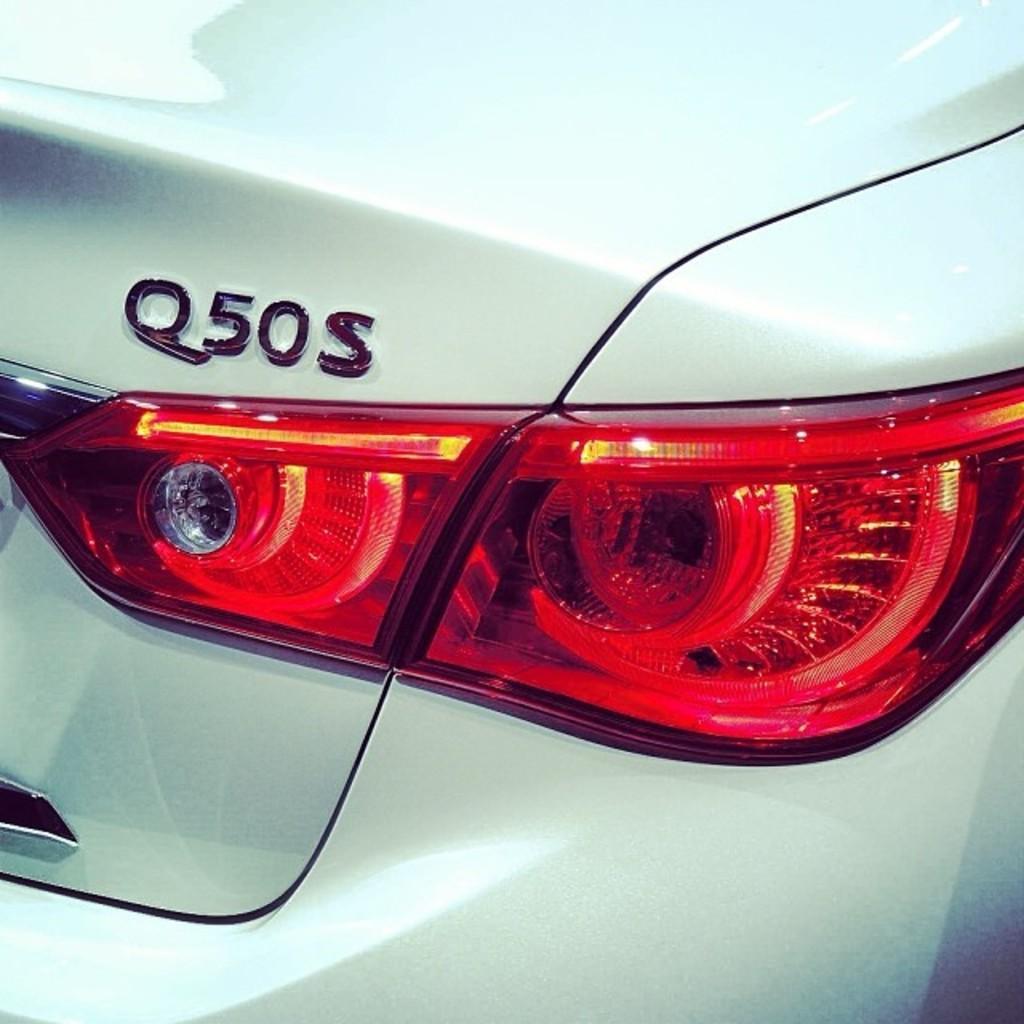How would you summarize this image in a sentence or two? In this image I can see a trunk and tail light of a car. 